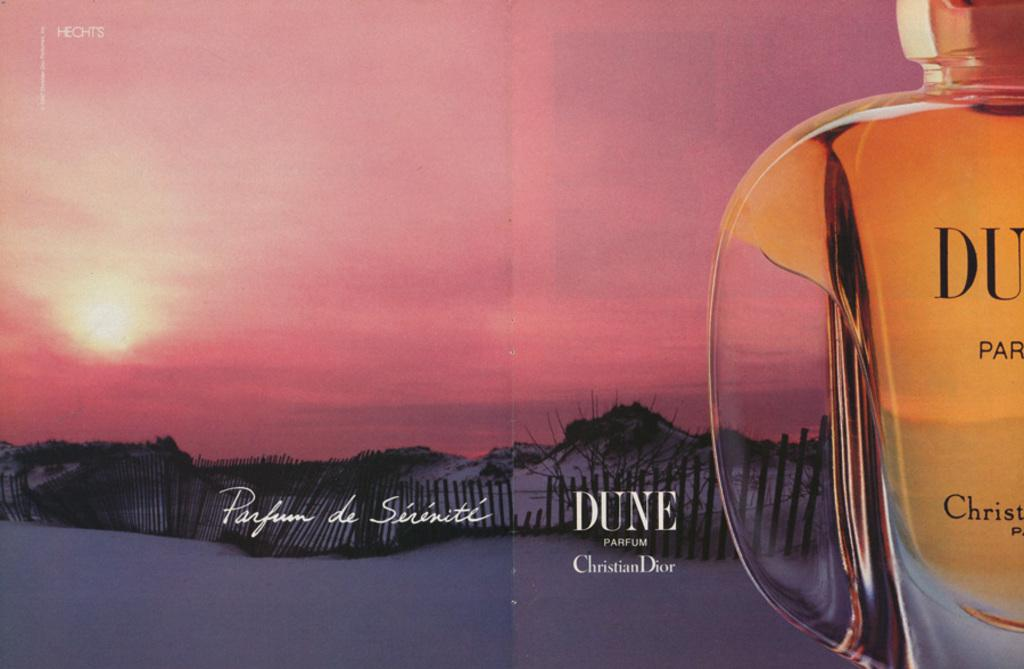<image>
Write a terse but informative summary of the picture. an ad for a perfum called DUNE by Christion Dior. 